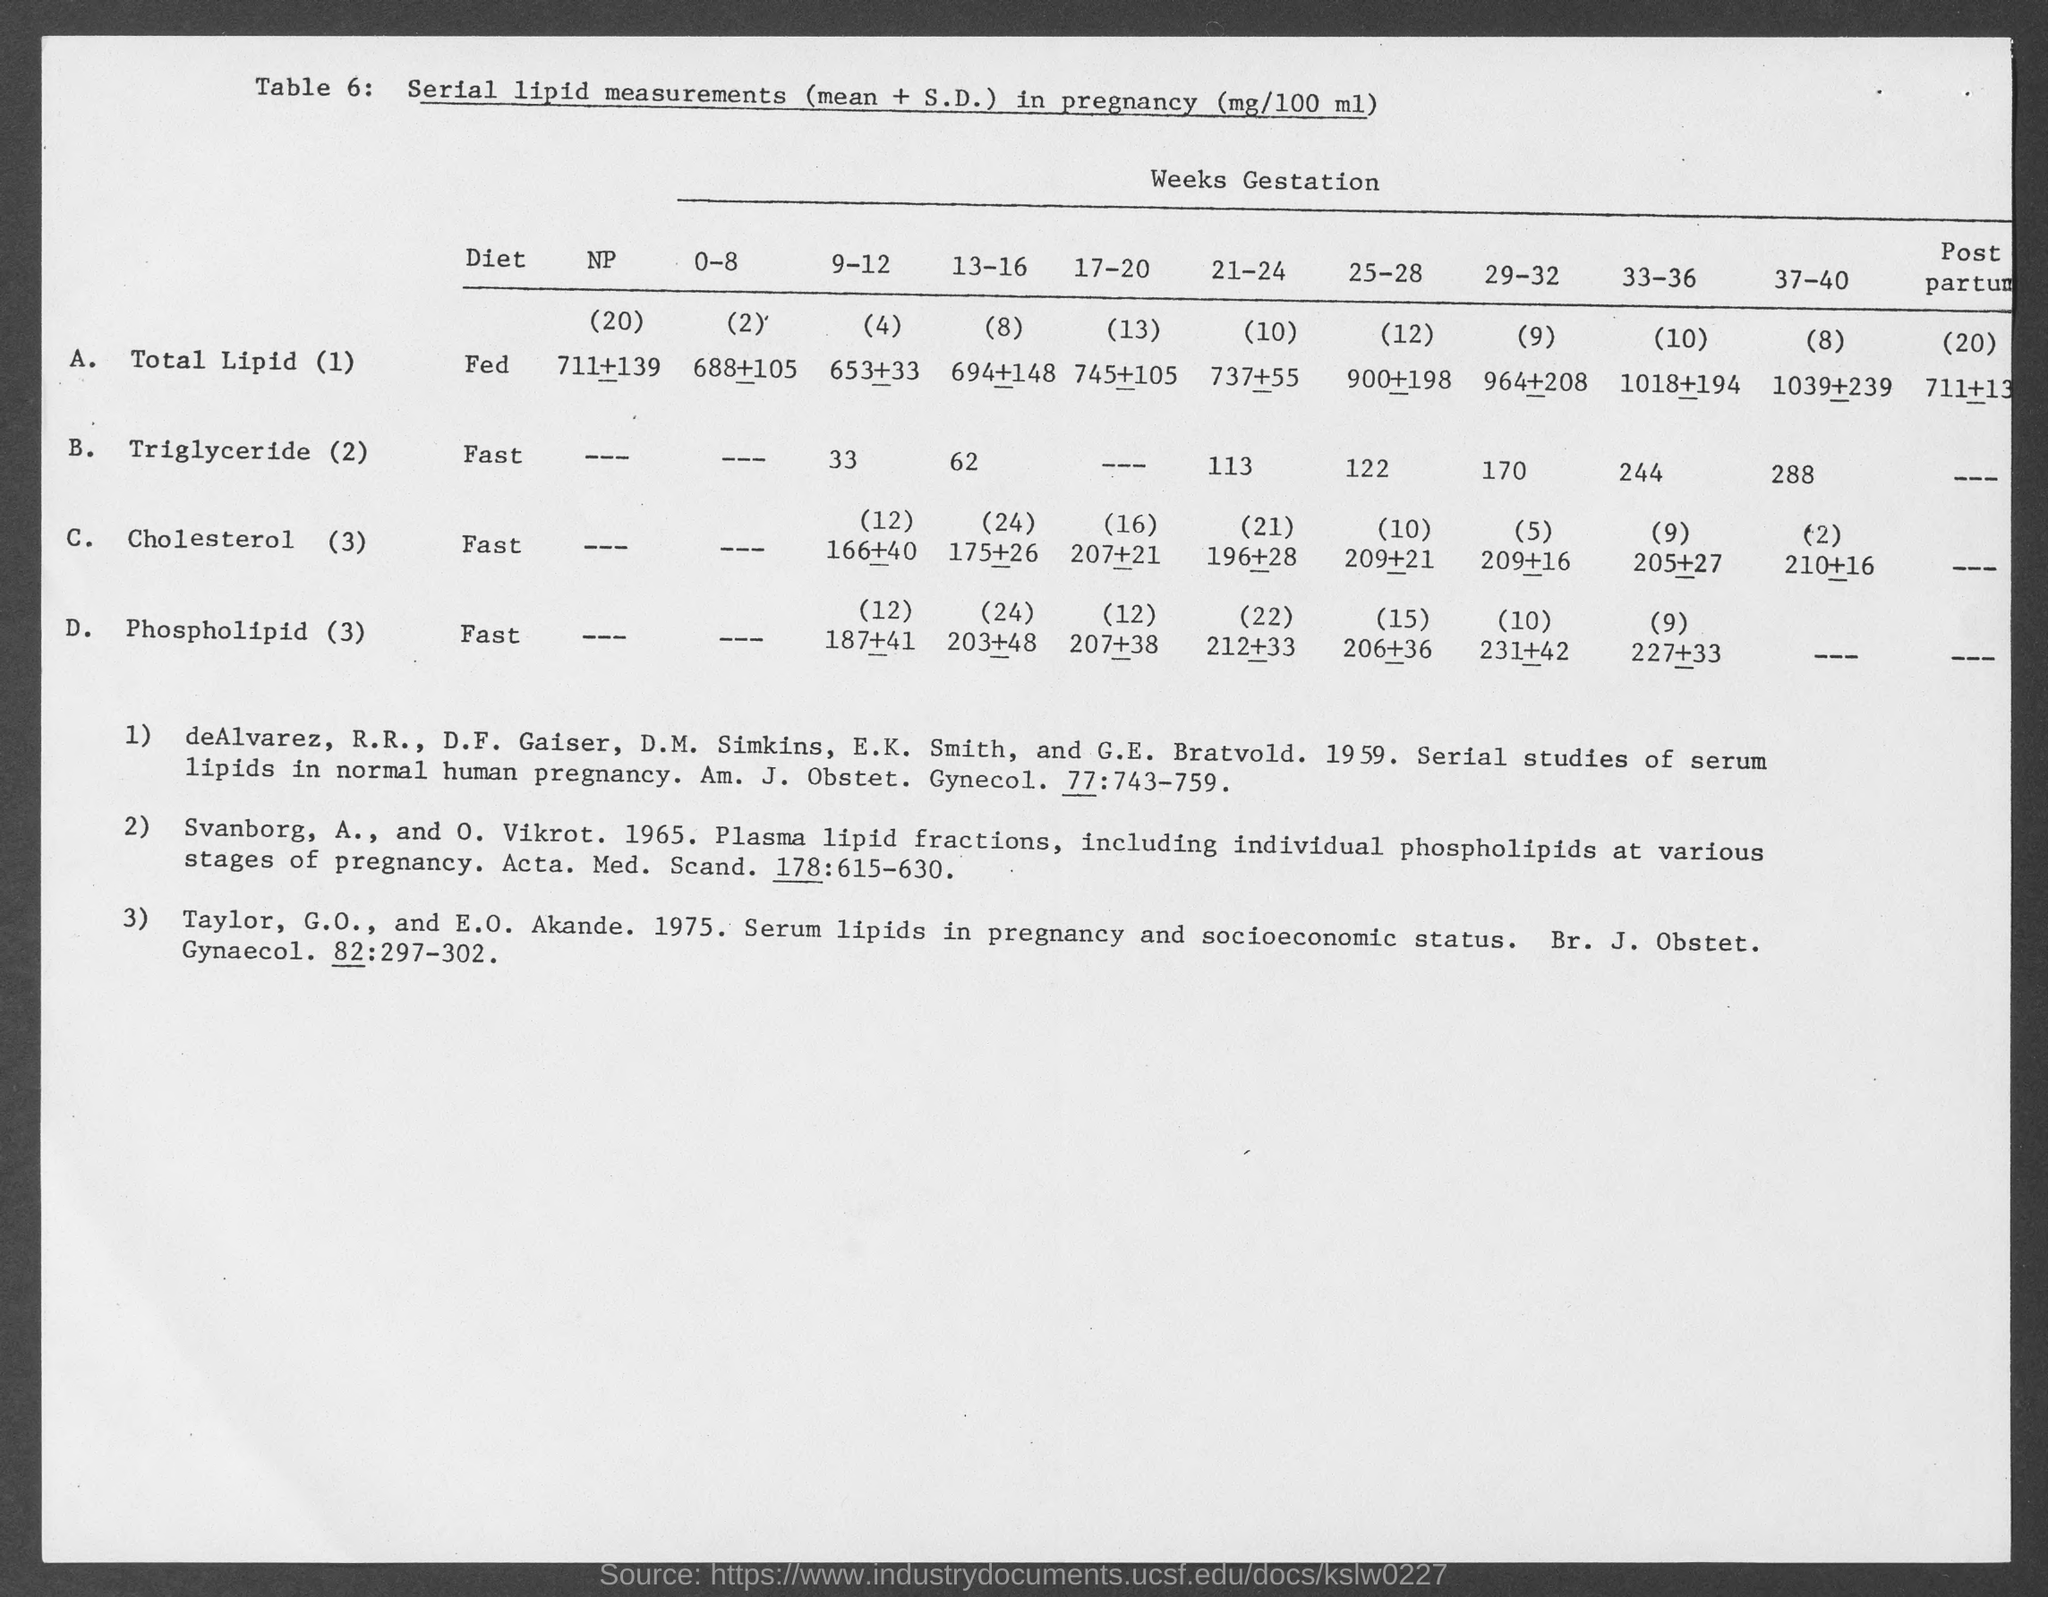Specify some key components in this picture. The type of diet for Total Lipid (1) fed is a specific nutritional plan designed to meet the nutritional requirements of the individual based on their specific Total Lipid (1) levels. The diet recommended for someone with high cholesterol is a fast diet. The diet for Triglyceride level 2 is a fasting diet. The table number is 6 and the table is referred to as Table 6. It has been determined that a fast diet is the appropriate type of diet for Phospholipid (3). 